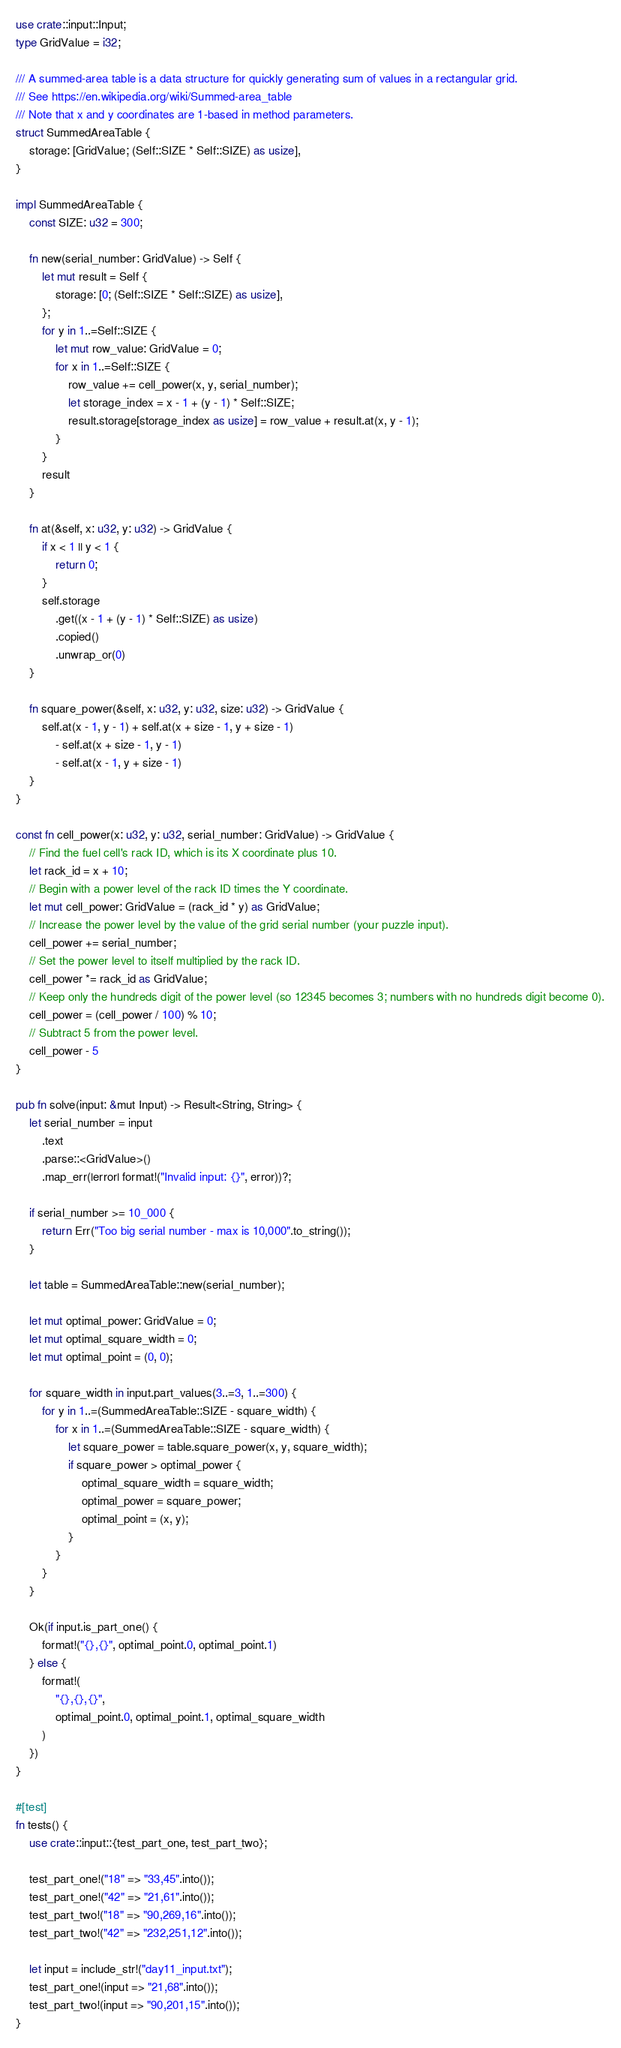Convert code to text. <code><loc_0><loc_0><loc_500><loc_500><_Rust_>use crate::input::Input;
type GridValue = i32;

/// A summed-area table is a data structure for quickly generating sum of values in a rectangular grid.
/// See https://en.wikipedia.org/wiki/Summed-area_table
/// Note that x and y coordinates are 1-based in method parameters.
struct SummedAreaTable {
    storage: [GridValue; (Self::SIZE * Self::SIZE) as usize],
}

impl SummedAreaTable {
    const SIZE: u32 = 300;

    fn new(serial_number: GridValue) -> Self {
        let mut result = Self {
            storage: [0; (Self::SIZE * Self::SIZE) as usize],
        };
        for y in 1..=Self::SIZE {
            let mut row_value: GridValue = 0;
            for x in 1..=Self::SIZE {
                row_value += cell_power(x, y, serial_number);
                let storage_index = x - 1 + (y - 1) * Self::SIZE;
                result.storage[storage_index as usize] = row_value + result.at(x, y - 1);
            }
        }
        result
    }

    fn at(&self, x: u32, y: u32) -> GridValue {
        if x < 1 || y < 1 {
            return 0;
        }
        self.storage
            .get((x - 1 + (y - 1) * Self::SIZE) as usize)
            .copied()
            .unwrap_or(0)
    }

    fn square_power(&self, x: u32, y: u32, size: u32) -> GridValue {
        self.at(x - 1, y - 1) + self.at(x + size - 1, y + size - 1)
            - self.at(x + size - 1, y - 1)
            - self.at(x - 1, y + size - 1)
    }
}

const fn cell_power(x: u32, y: u32, serial_number: GridValue) -> GridValue {
    // Find the fuel cell's rack ID, which is its X coordinate plus 10.
    let rack_id = x + 10;
    // Begin with a power level of the rack ID times the Y coordinate.
    let mut cell_power: GridValue = (rack_id * y) as GridValue;
    // Increase the power level by the value of the grid serial number (your puzzle input).
    cell_power += serial_number;
    // Set the power level to itself multiplied by the rack ID.
    cell_power *= rack_id as GridValue;
    // Keep only the hundreds digit of the power level (so 12345 becomes 3; numbers with no hundreds digit become 0).
    cell_power = (cell_power / 100) % 10;
    // Subtract 5 from the power level.
    cell_power - 5
}

pub fn solve(input: &mut Input) -> Result<String, String> {
    let serial_number = input
        .text
        .parse::<GridValue>()
        .map_err(|error| format!("Invalid input: {}", error))?;

    if serial_number >= 10_000 {
        return Err("Too big serial number - max is 10,000".to_string());
    }

    let table = SummedAreaTable::new(serial_number);

    let mut optimal_power: GridValue = 0;
    let mut optimal_square_width = 0;
    let mut optimal_point = (0, 0);

    for square_width in input.part_values(3..=3, 1..=300) {
        for y in 1..=(SummedAreaTable::SIZE - square_width) {
            for x in 1..=(SummedAreaTable::SIZE - square_width) {
                let square_power = table.square_power(x, y, square_width);
                if square_power > optimal_power {
                    optimal_square_width = square_width;
                    optimal_power = square_power;
                    optimal_point = (x, y);
                }
            }
        }
    }

    Ok(if input.is_part_one() {
        format!("{},{}", optimal_point.0, optimal_point.1)
    } else {
        format!(
            "{},{},{}",
            optimal_point.0, optimal_point.1, optimal_square_width
        )
    })
}

#[test]
fn tests() {
    use crate::input::{test_part_one, test_part_two};

    test_part_one!("18" => "33,45".into());
    test_part_one!("42" => "21,61".into());
    test_part_two!("18" => "90,269,16".into());
    test_part_two!("42" => "232,251,12".into());

    let input = include_str!("day11_input.txt");
    test_part_one!(input => "21,68".into());
    test_part_two!(input => "90,201,15".into());
}
</code> 